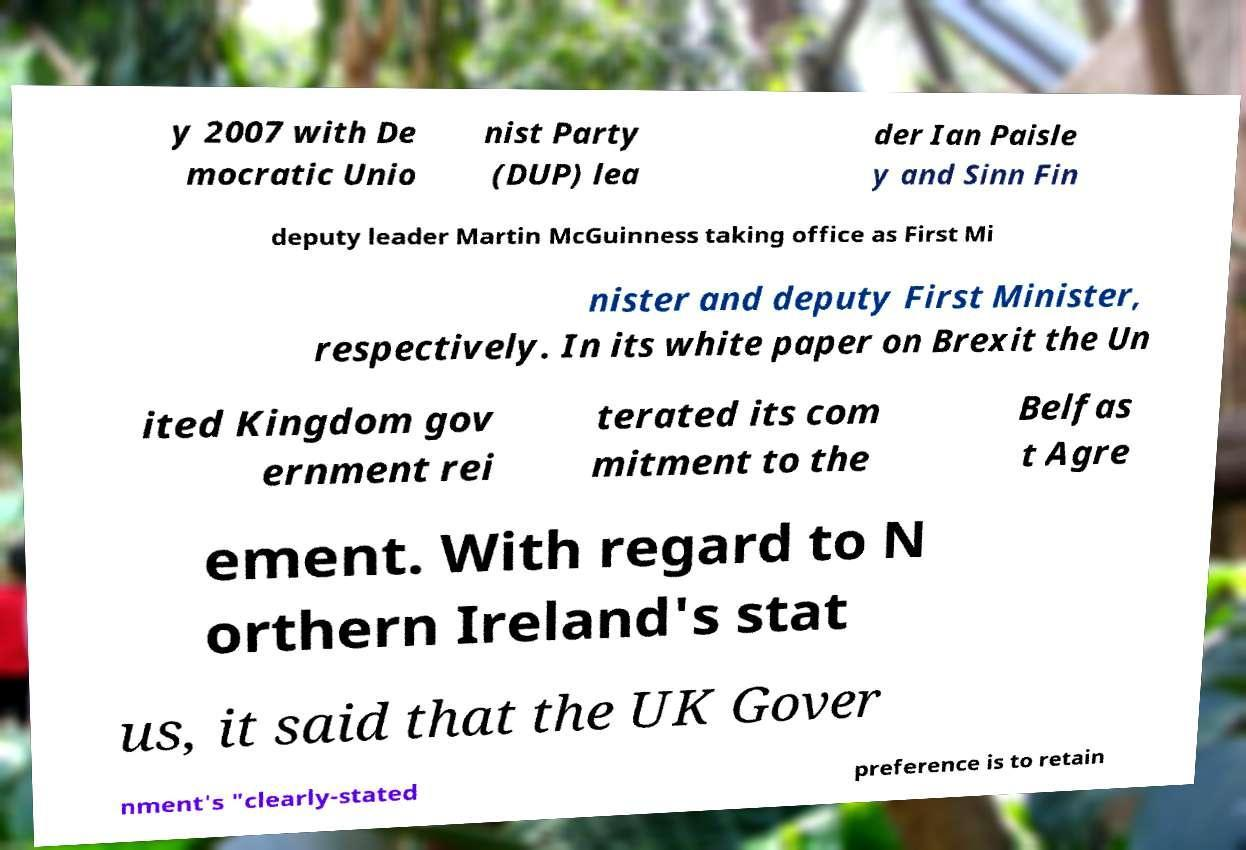Please read and relay the text visible in this image. What does it say? y 2007 with De mocratic Unio nist Party (DUP) lea der Ian Paisle y and Sinn Fin deputy leader Martin McGuinness taking office as First Mi nister and deputy First Minister, respectively. In its white paper on Brexit the Un ited Kingdom gov ernment rei terated its com mitment to the Belfas t Agre ement. With regard to N orthern Ireland's stat us, it said that the UK Gover nment's "clearly-stated preference is to retain 